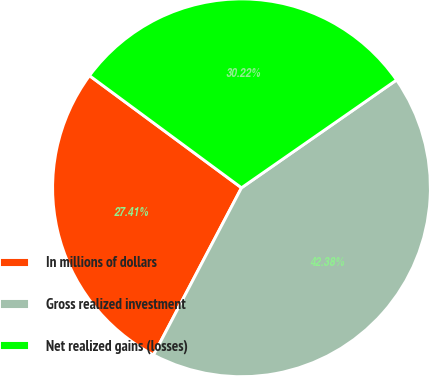<chart> <loc_0><loc_0><loc_500><loc_500><pie_chart><fcel>In millions of dollars<fcel>Gross realized investment<fcel>Net realized gains (losses)<nl><fcel>27.41%<fcel>42.38%<fcel>30.22%<nl></chart> 